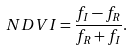<formula> <loc_0><loc_0><loc_500><loc_500>N D V I = \frac { f _ { I } - f _ { R } } { f _ { R } + f _ { I } } .</formula> 